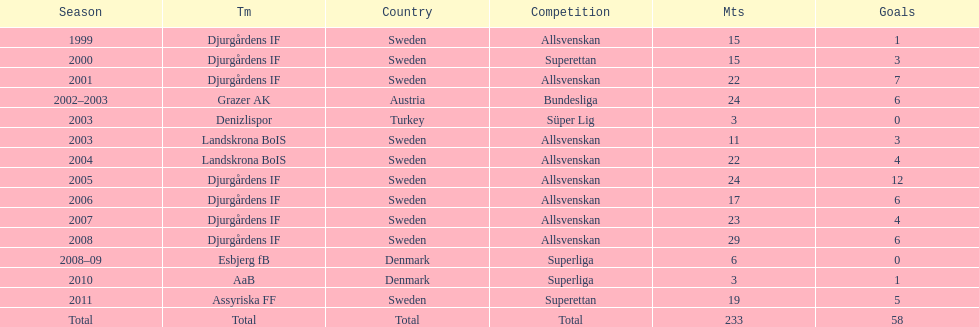How many matches did jones kusi-asare play in in his first season? 15. 